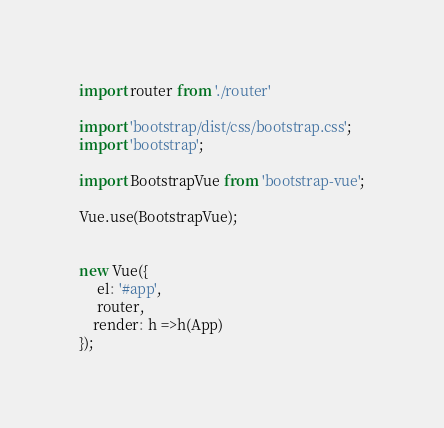Convert code to text. <code><loc_0><loc_0><loc_500><loc_500><_JavaScript_>
import router from './router'

import 'bootstrap/dist/css/bootstrap.css';
import 'bootstrap';

import BootstrapVue from 'bootstrap-vue';

Vue.use(BootstrapVue);


new Vue({
     el: '#app',
     router, 
    render: h =>h(App)
});
</code> 